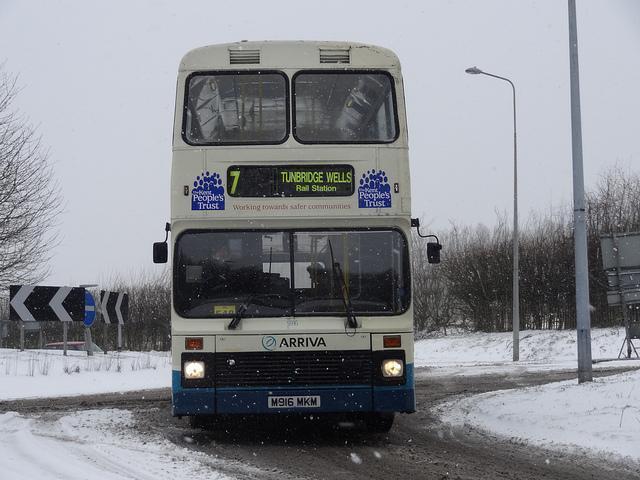How many horses are there?
Give a very brief answer. 0. 